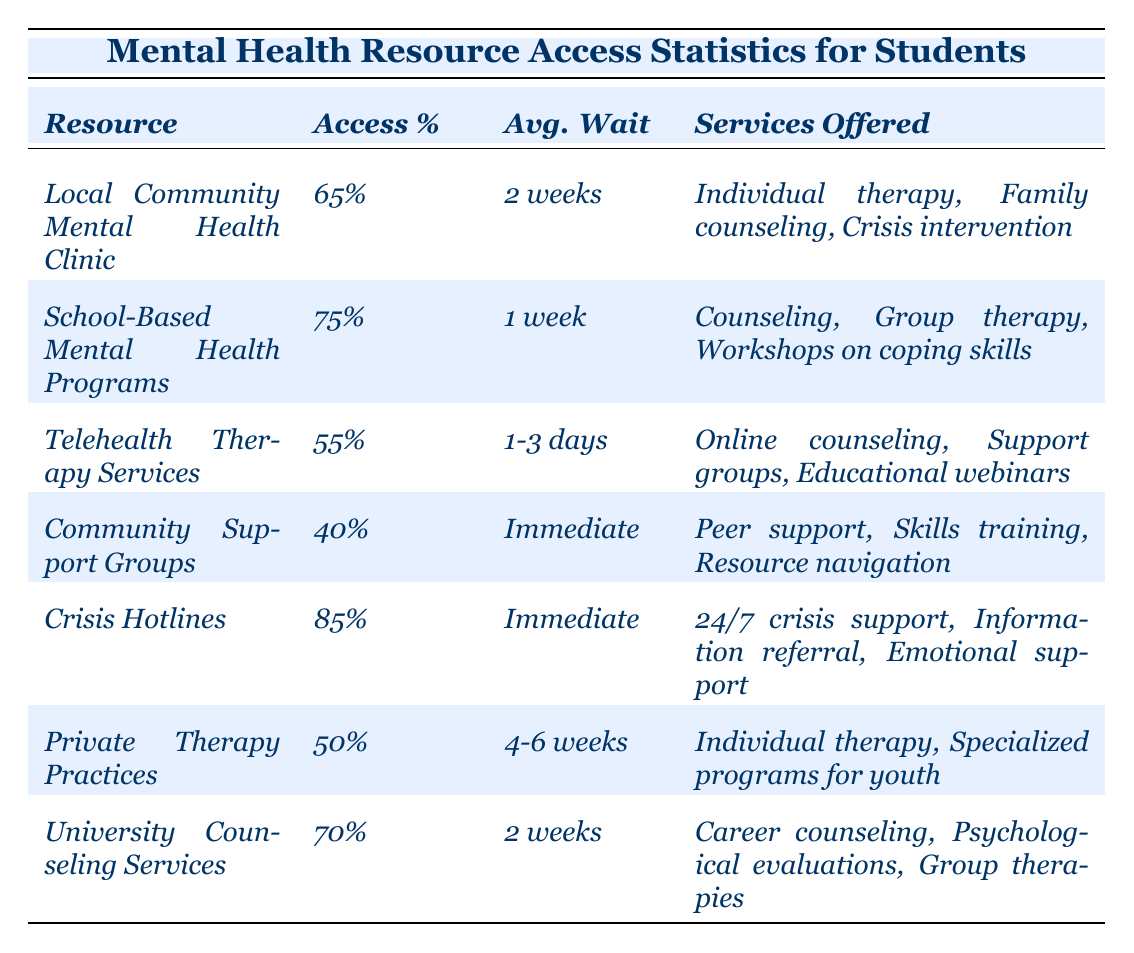What resource has the highest access percentage? By reviewing the Access % column, Crisis Hotlines is listed with the highest value of 85%.
Answer: Crisis Hotlines Which resource has the longest average wait time? The Private Therapy Practices show the longest wait time of 4-6 weeks when compared to other resources listed.
Answer: Private Therapy Practices How many resources have an access percentage of 70% or higher? By counting the resources in the Access % column, there are four resources (School-Based Mental Health Programs, Crisis Hotlines, University Counseling Services) that meet this criterion.
Answer: Four Is the average wait time for Telehealth Therapy Services shorter than that for the Local Community Mental Health Clinic? The average wait time for Telehealth Therapy Services (1-3 days) is shorter than the wait time for the Local Community Mental Health Clinic (2 weeks).
Answer: Yes Calculate the average access percentage of all resources listed. Summing the access percentages: 65 + 75 + 55 + 40 + 85 + 50 + 70 = 440, then dividing by 7 resources gives an average of 440 / 7 ≈ 62.86%.
Answer: Approximately 62.86% Does any resource provide support immediately? By looking under the Avg. Wait column, both Community Support Groups and Crisis Hotlines indicate "Immediate" wait times for service access.
Answer: Yes Which resource offers services specifically for youth? Only the Private Therapy Practices include specialized programs for youth in their services offered.
Answer: Private Therapy Practices Is the wait time for School-Based Mental Health Programs shorter than that for University Counseling Services? The average wait time for School-Based Mental Health Programs (1 week) is shorter than the wait time for University Counseling Services (2 weeks).
Answer: Yes What is the difference in access percentage between the resource with the highest and lowest access? The Crisis Hotlines have the highest access percentage at 85%, and Community Support Groups have the lowest at 40%. The difference is 85 - 40 = 45%.
Answer: 45% Which resource provides online services? The Telehealth Therapy Services offer online counseling, as indicated in the Services Offered column.
Answer: Telehealth Therapy Services 